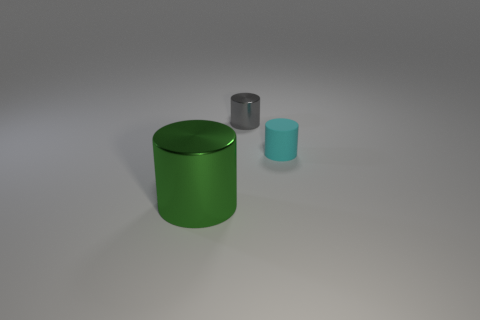Subtract all metallic cylinders. How many cylinders are left? 1 Add 3 tiny gray shiny things. How many objects exist? 6 Subtract all gray cylinders. How many cylinders are left? 2 Subtract all green cylinders. Subtract all big objects. How many objects are left? 1 Add 1 cyan matte cylinders. How many cyan matte cylinders are left? 2 Add 2 small gray objects. How many small gray objects exist? 3 Subtract 0 brown balls. How many objects are left? 3 Subtract all brown cylinders. Subtract all red cubes. How many cylinders are left? 3 